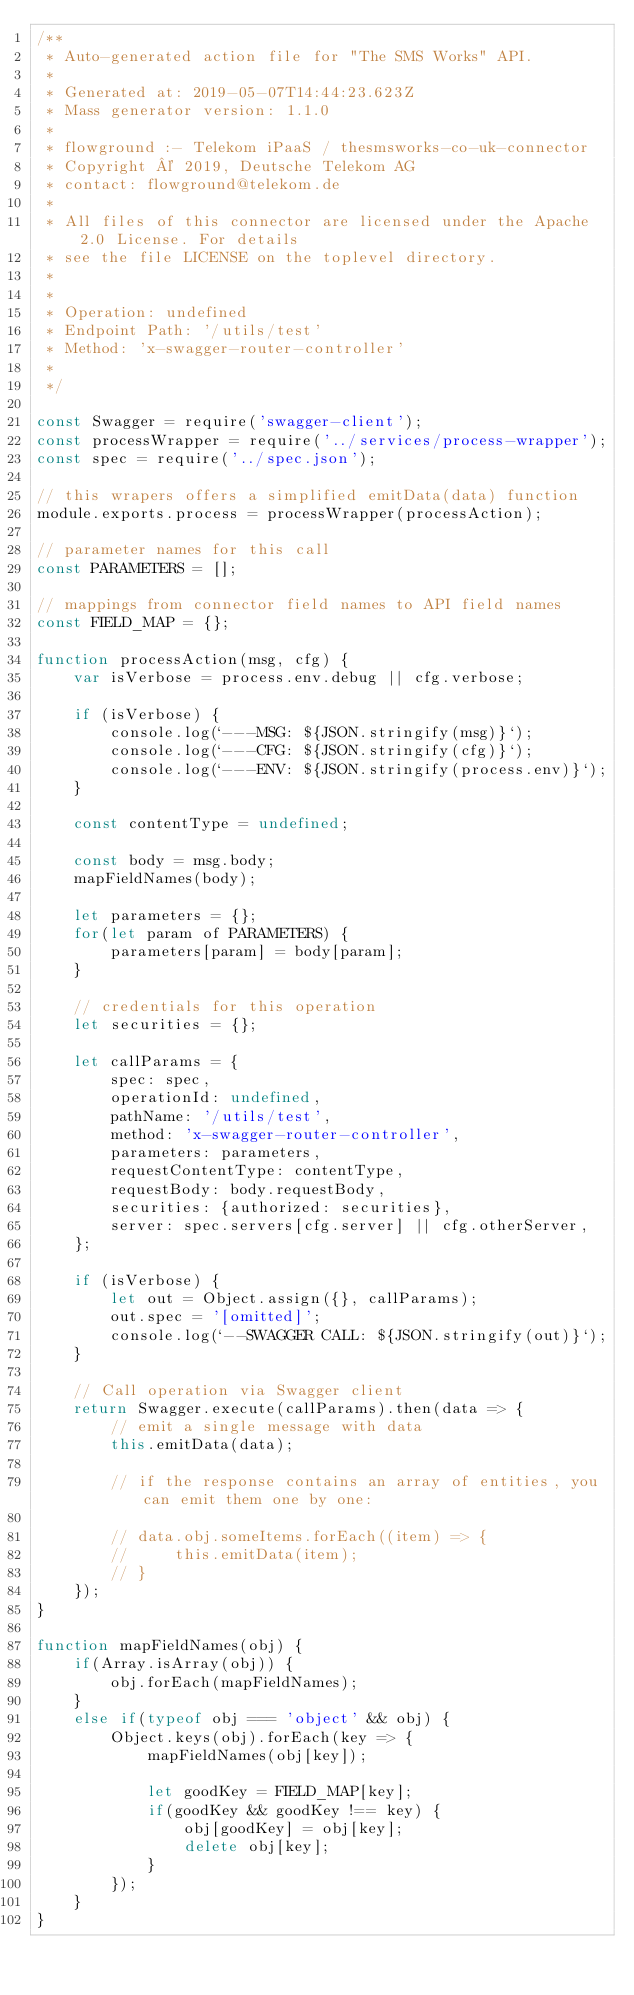Convert code to text. <code><loc_0><loc_0><loc_500><loc_500><_JavaScript_>/**
 * Auto-generated action file for "The SMS Works" API.
 *
 * Generated at: 2019-05-07T14:44:23.623Z
 * Mass generator version: 1.1.0
 *
 * flowground :- Telekom iPaaS / thesmsworks-co-uk-connector
 * Copyright © 2019, Deutsche Telekom AG
 * contact: flowground@telekom.de
 *
 * All files of this connector are licensed under the Apache 2.0 License. For details
 * see the file LICENSE on the toplevel directory.
 *
 *
 * Operation: undefined
 * Endpoint Path: '/utils/test'
 * Method: 'x-swagger-router-controller'
 *
 */

const Swagger = require('swagger-client');
const processWrapper = require('../services/process-wrapper');
const spec = require('../spec.json');

// this wrapers offers a simplified emitData(data) function
module.exports.process = processWrapper(processAction);

// parameter names for this call
const PARAMETERS = [];

// mappings from connector field names to API field names
const FIELD_MAP = {};

function processAction(msg, cfg) {
    var isVerbose = process.env.debug || cfg.verbose;

    if (isVerbose) {
        console.log(`---MSG: ${JSON.stringify(msg)}`);
        console.log(`---CFG: ${JSON.stringify(cfg)}`);
        console.log(`---ENV: ${JSON.stringify(process.env)}`);
    }

    const contentType = undefined;

    const body = msg.body;
    mapFieldNames(body);

    let parameters = {};
    for(let param of PARAMETERS) {
        parameters[param] = body[param];
    }

    // credentials for this operation
    let securities = {};

    let callParams = {
        spec: spec,
        operationId: undefined,
        pathName: '/utils/test',
        method: 'x-swagger-router-controller',
        parameters: parameters,
        requestContentType: contentType,
        requestBody: body.requestBody,
        securities: {authorized: securities},
        server: spec.servers[cfg.server] || cfg.otherServer,
    };

    if (isVerbose) {
        let out = Object.assign({}, callParams);
        out.spec = '[omitted]';
        console.log(`--SWAGGER CALL: ${JSON.stringify(out)}`);
    }

    // Call operation via Swagger client
    return Swagger.execute(callParams).then(data => {
        // emit a single message with data
        this.emitData(data);

        // if the response contains an array of entities, you can emit them one by one:

        // data.obj.someItems.forEach((item) => {
        //     this.emitData(item);
        // }
    });
}

function mapFieldNames(obj) {
    if(Array.isArray(obj)) {
        obj.forEach(mapFieldNames);
    }
    else if(typeof obj === 'object' && obj) {
        Object.keys(obj).forEach(key => {
            mapFieldNames(obj[key]);

            let goodKey = FIELD_MAP[key];
            if(goodKey && goodKey !== key) {
                obj[goodKey] = obj[key];
                delete obj[key];
            }
        });
    }
}</code> 